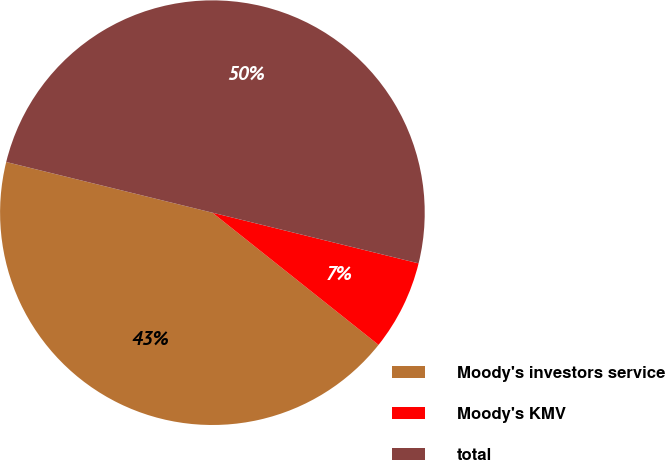Convert chart. <chart><loc_0><loc_0><loc_500><loc_500><pie_chart><fcel>Moody's investors service<fcel>Moody's KMV<fcel>total<nl><fcel>43.14%<fcel>6.86%<fcel>50.0%<nl></chart> 